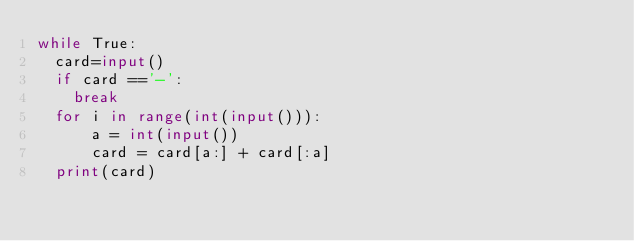<code> <loc_0><loc_0><loc_500><loc_500><_Python_>while True:
  card=input()
  if card =='-':
    break
  for i in range(int(input())):
      a = int(input())
      card = card[a:] + card[:a]
  print(card)
</code> 